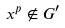<formula> <loc_0><loc_0><loc_500><loc_500>x ^ { p } \notin G ^ { \prime }</formula> 